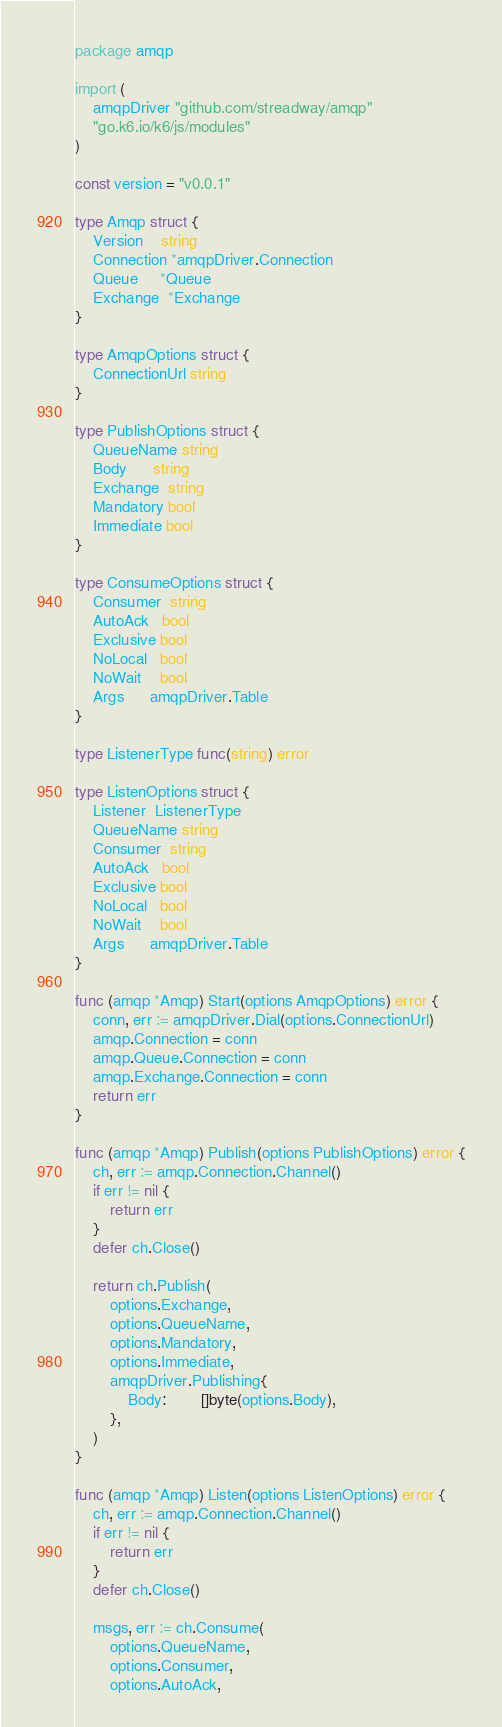<code> <loc_0><loc_0><loc_500><loc_500><_Go_>package amqp

import (
	amqpDriver "github.com/streadway/amqp"
	"go.k6.io/k6/js/modules"
)

const version = "v0.0.1"

type Amqp struct {
	Version    string
	Connection *amqpDriver.Connection
	Queue     *Queue
	Exchange  *Exchange
}

type AmqpOptions struct {
	ConnectionUrl string
}

type PublishOptions struct {
	QueueName string
	Body      string
	Exchange  string
	Mandatory bool
	Immediate bool
}

type ConsumeOptions struct {
	Consumer  string
	AutoAck   bool
	Exclusive bool
	NoLocal   bool
	NoWait    bool
	Args      amqpDriver.Table
}

type ListenerType func(string) error

type ListenOptions struct {
	Listener  ListenerType
	QueueName string
	Consumer  string
	AutoAck   bool
	Exclusive bool
	NoLocal   bool
	NoWait    bool
	Args      amqpDriver.Table
}

func (amqp *Amqp) Start(options AmqpOptions) error {
	conn, err := amqpDriver.Dial(options.ConnectionUrl)
	amqp.Connection = conn
	amqp.Queue.Connection = conn
	amqp.Exchange.Connection = conn
	return err
}

func (amqp *Amqp) Publish(options PublishOptions) error {
	ch, err := amqp.Connection.Channel()
	if err != nil {
		return err
	}
	defer ch.Close()

	return ch.Publish(
		options.Exchange,
		options.QueueName,
		options.Mandatory,
		options.Immediate,
		amqpDriver.Publishing{
			Body:        []byte(options.Body),
		},
	)
}

func (amqp *Amqp) Listen(options ListenOptions) error {
	ch, err := amqp.Connection.Channel()
	if err != nil {
		return err
	}
	defer ch.Close()

	msgs, err := ch.Consume(
		options.QueueName,
		options.Consumer,
		options.AutoAck,</code> 